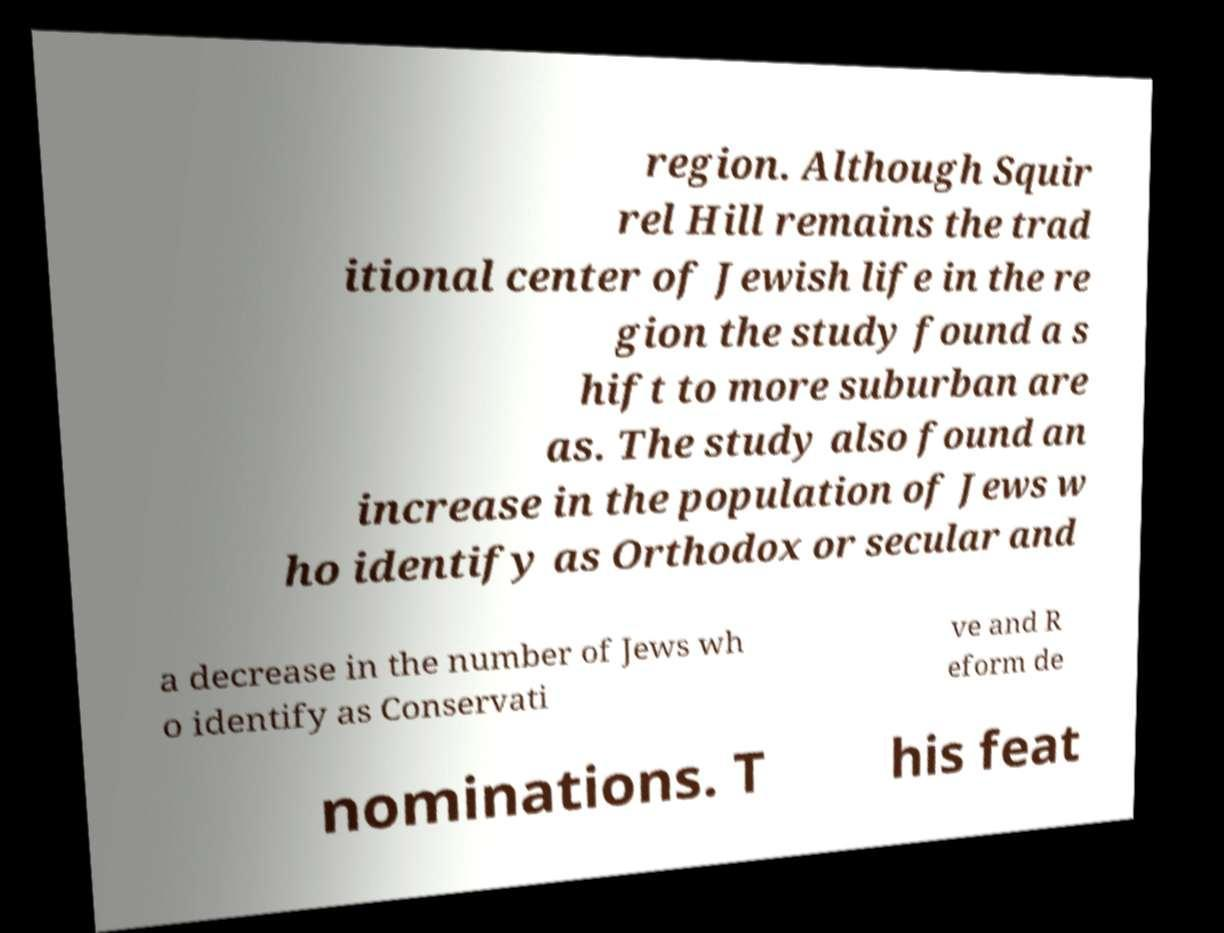Please read and relay the text visible in this image. What does it say? region. Although Squir rel Hill remains the trad itional center of Jewish life in the re gion the study found a s hift to more suburban are as. The study also found an increase in the population of Jews w ho identify as Orthodox or secular and a decrease in the number of Jews wh o identify as Conservati ve and R eform de nominations. T his feat 